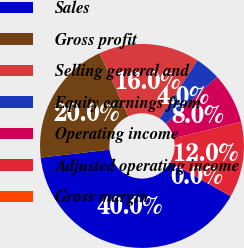Convert chart to OTSL. <chart><loc_0><loc_0><loc_500><loc_500><pie_chart><fcel>Sales<fcel>Gross profit<fcel>Selling general and<fcel>Equity earnings from<fcel>Operating income<fcel>Adjusted operating income<fcel>Gross margin<nl><fcel>39.97%<fcel>19.99%<fcel>16.0%<fcel>4.01%<fcel>8.01%<fcel>12.0%<fcel>0.02%<nl></chart> 